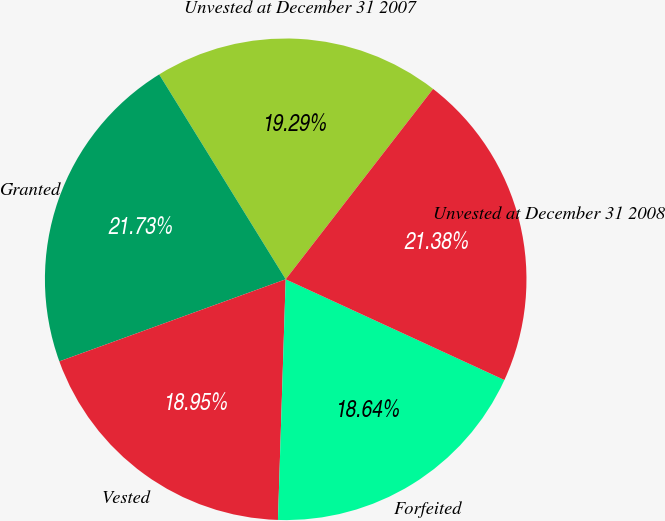<chart> <loc_0><loc_0><loc_500><loc_500><pie_chart><fcel>Unvested at December 31 2007<fcel>Granted<fcel>Vested<fcel>Forfeited<fcel>Unvested at December 31 2008<nl><fcel>19.29%<fcel>21.73%<fcel>18.95%<fcel>18.64%<fcel>21.38%<nl></chart> 